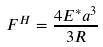Convert formula to latex. <formula><loc_0><loc_0><loc_500><loc_500>F ^ { H } = \frac { 4 E ^ { * } a ^ { 3 } } { 3 R }</formula> 